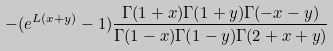Convert formula to latex. <formula><loc_0><loc_0><loc_500><loc_500>- ( e ^ { L ( x + y ) } - 1 ) \frac { \Gamma ( 1 + x ) \Gamma ( 1 + y ) \Gamma ( - x - y ) } { \Gamma ( 1 - x ) \Gamma ( 1 - y ) \Gamma ( 2 + x + y ) }</formula> 